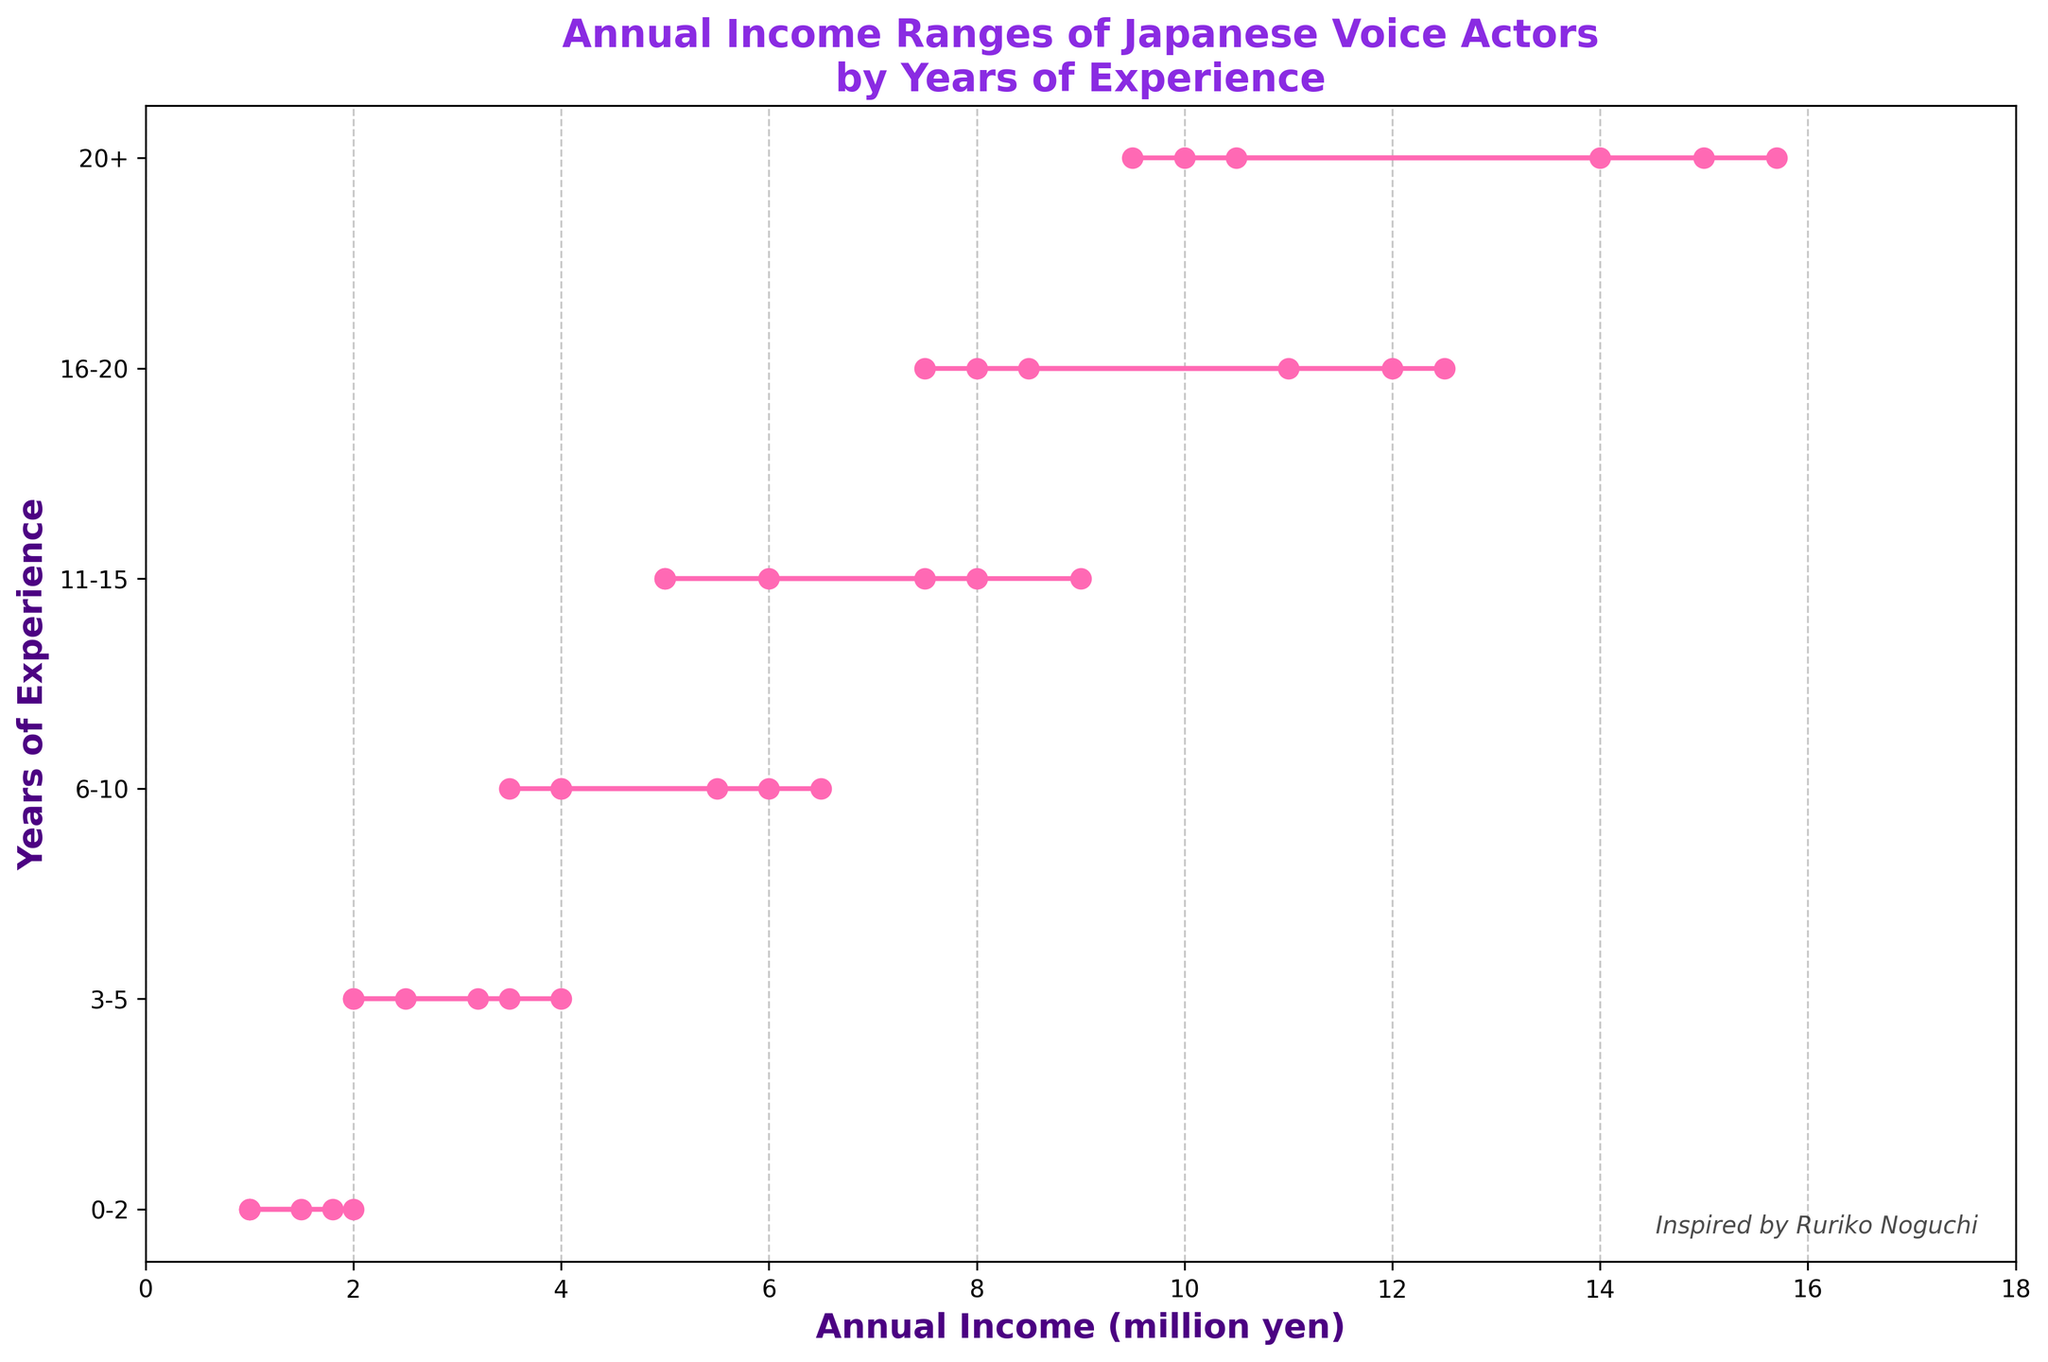What is the title of the plot? The title of the plot is the text displayed at the top of the figure. It provides a concise description of the information presented in the chart. By looking at the top of the plot, we can see that the title reads "Annual Income Ranges of Japanese Voice Actors by Years of Experience"
Answer: Annual Income Ranges of Japanese Voice Actors by Years of Experience What is the range of annual income for voice actors with 0-2 years of experience? The range of annual income for voice actors with 0-2 years of experience can be found on the horizontal axis, with corresponding data points along the vertical axis labeled "0-2". The range is captured by examining the two extremes of the income lines for this group.
Answer: 1-2 million yen For the 11-15 years of experience group, what is the highest annual income range depicted? Look at the data points plotted for the 11-15 years of experience group. The highest range is indicated by the maximum value seen in this category. From the plot, the highest range is observed at the top end of the income lines for this group.
Answer: 6-9 million yen How does the income range for voice actors with 6-10 years of experience compare to those with 16-20 years of experience? To compare the income ranges, look at the plotted lines for the 6-10 years and 16-20 years categories. Identify the minimum and maximum values for each group and then perform a comparison between both. The income range for 6-10 years is between 3.5 and 6.5 million yen, while for 16-20 years it is between 7.5 and 12.5 million yen. Thus, the income range for the 16-20 years group is higher.
Answer: Higher for 16-20 years What is the minimum annual income for voice actors with more than 20 years of experience? Look at the horizontal lines plotted for the "20+" years of experience category. Identify the lowest point on the horizontal axis among these lines to find the minimum annual income for this group.
Answer: 9.5 million yen What trend is observed as the years of experience increase from 0-2 to 20+? Observe the plotted lines for each experience category from left to right along the vertical axis. The income ranges tend to move higher on the horizontal axis as the years of experience increase, indicating that more experienced voice actors generally have higher annual incomes.
Answer: Increase in annual income What is the widest range of annual income observed in the plot and for which experience category? To determine the widest range, compare the difference between the maximum and minimum values of annual income for each experience category. Calculate the range for each category and then identify the largest one. The widest range is for the "20+" years category, which ranges from 9.5 to 15.7 million yen, a difference of 6.2 million yen.
Answer: 6.2 million yen for 20+ years 